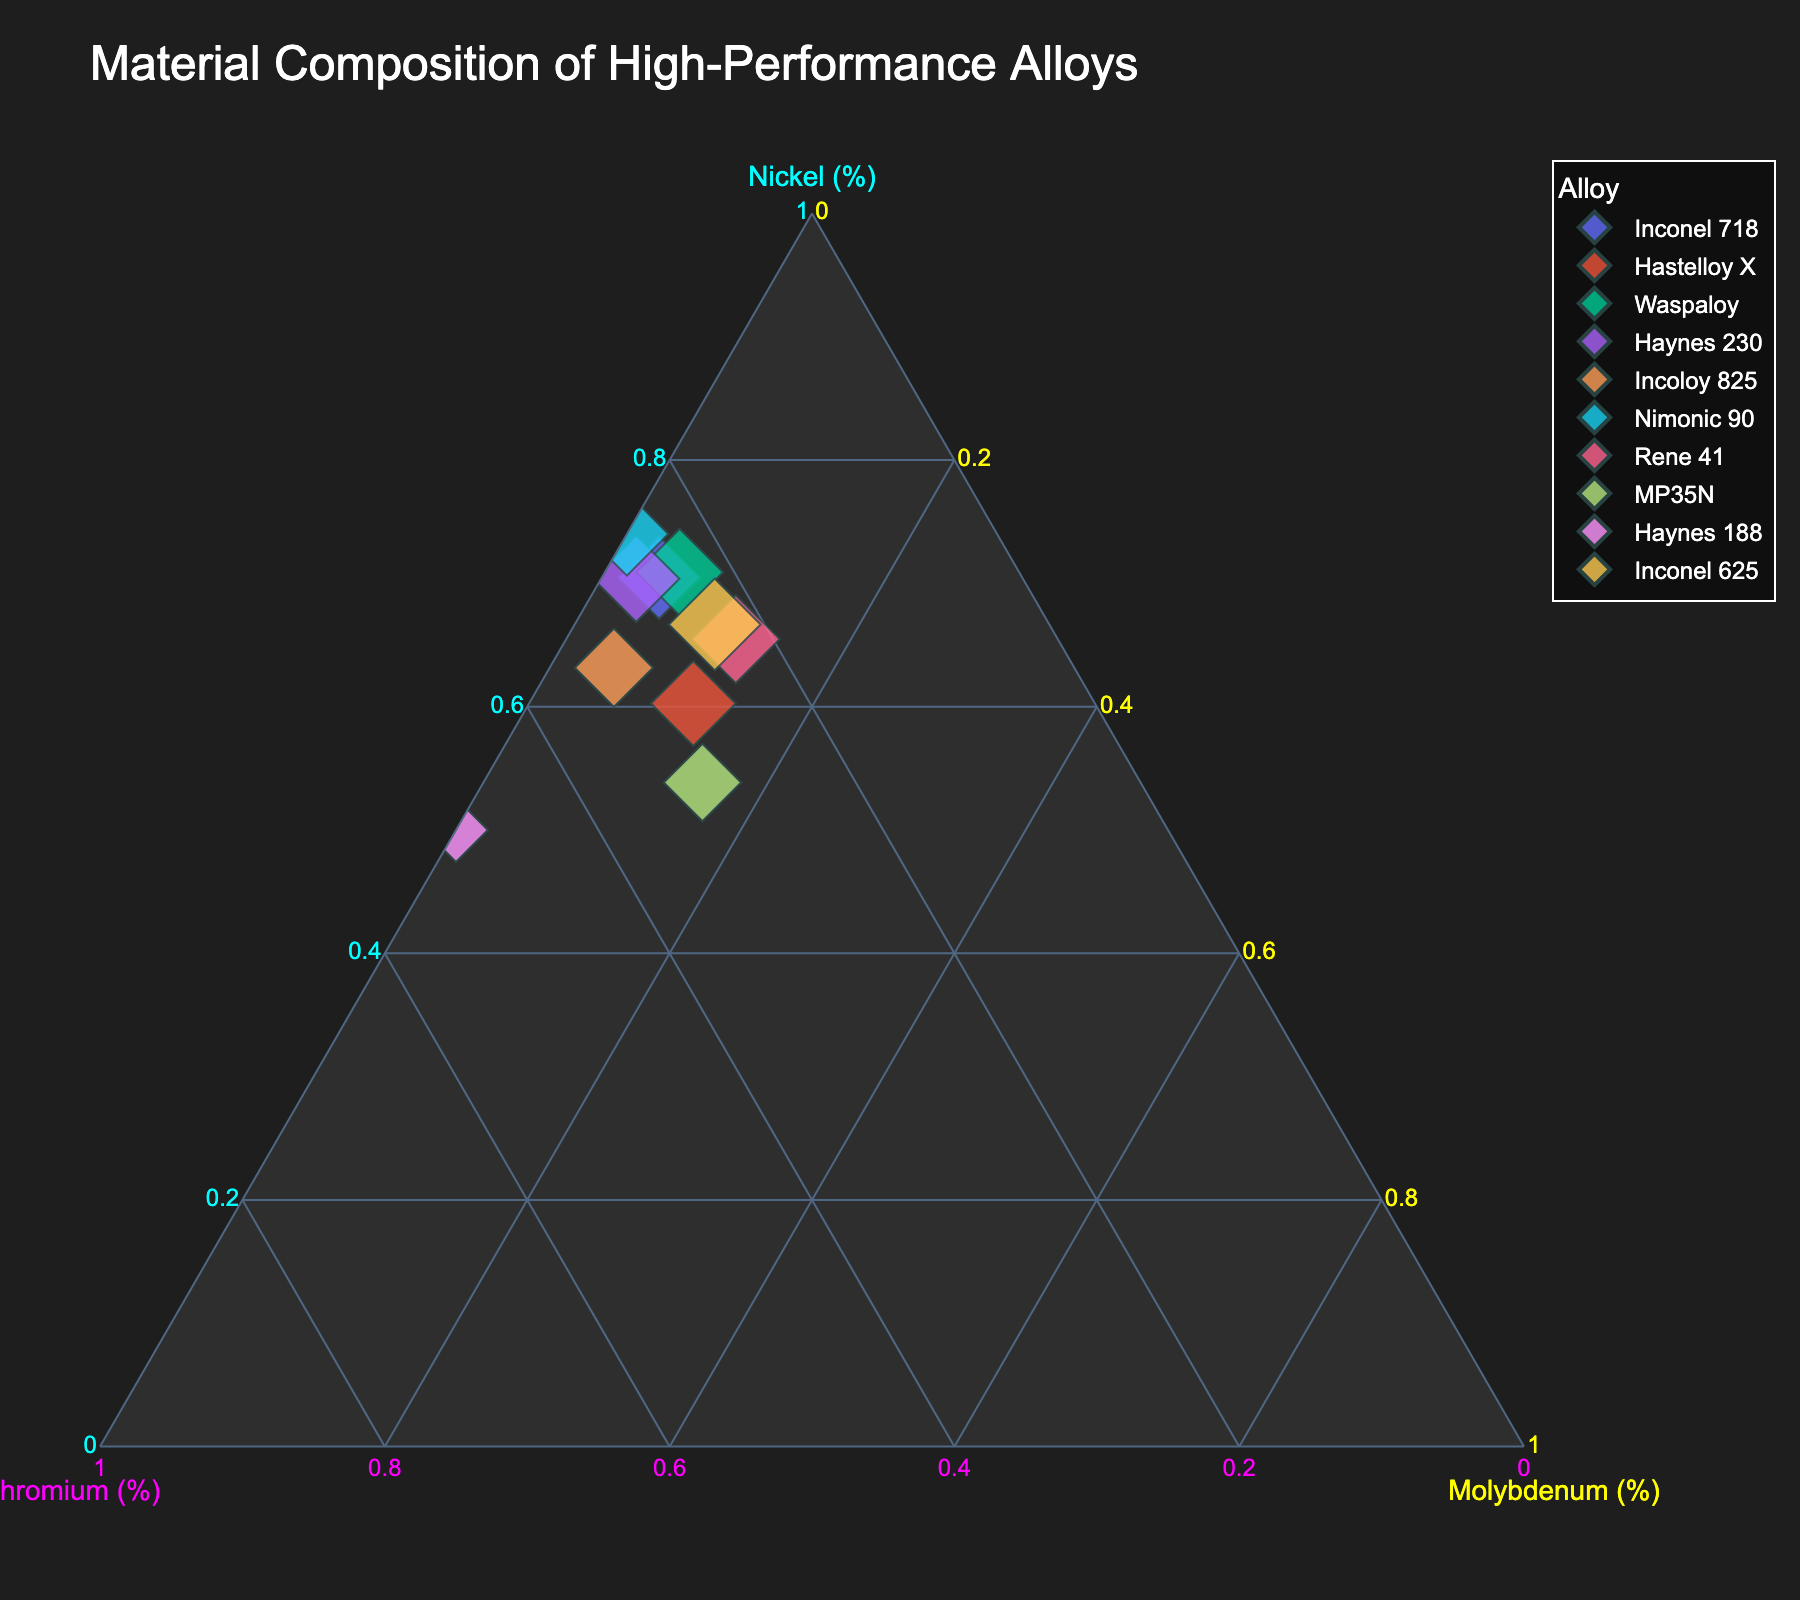What is the title of the plot? The title is located at the top of the plot, providing a summary of what the plot represents.
Answer: Material Composition of High-Performance Alloys How many alloys are shown in the plot? By counting the distinct data points or names of the alloys appearing in the legend, you can determine the number of alloys.
Answer: 10 Which alloy contains the highest percentage of Nickel? Find the point closest to the apex labeled Nickel (%) on the ternary plot.
Answer: Inconel 625 Which alloy has the smallest total composition sum? By observing the size of the markers, determine the smallest one, as size corresponds to the total composition sum.
Answer: Haynes 188 What are the three elements displayed in the ternary plot? Check the three axes of the ternary plot to identify the elements.
Answer: Nickel, Chromium, Molybdenum Which alloy has the highest proportion of Molybdenum? Locate the point closest to the apex labeled Molybdenum (%) on the ternary plot.
Answer: Rene 41 Compare the Molybdenum content of Hastelloy X and Incoloy 825; which is higher? Find the positions of both alloys on the ternary plot, specifically their proximity to the Molybdenum (%) apex, and compare.
Answer: Hastelloy X Which alloy is positioned furthest away from the Chromium (%) apex? Identify the point that is the furthest from the apex designated Chromium (%) on the ternary plot.
Answer: Nimonic 90 If you classify alloys by dominant elements, how many alloys have Nickel as the dominant element? Count the number of points nearest to the Nickel (%) apex, indicating that Nickel is the predominant element.
Answer: 6 Are there any alloys with a Molybdenum content exactly equal to 10%? Locate any points that lie directly on the line representing 10% Molybdenum from the apex.
Answer: Yes, MP35N and Rene 41 